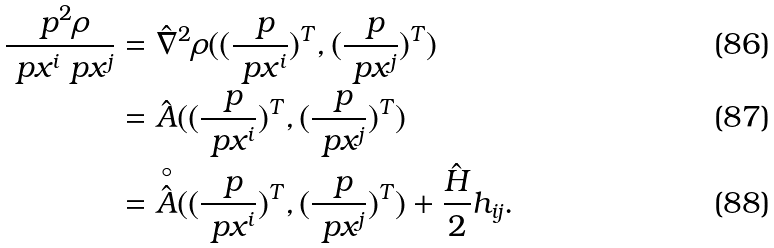<formula> <loc_0><loc_0><loc_500><loc_500>\frac { \ p ^ { 2 } \rho } { \ p x ^ { i } \ p x ^ { j } } & = \hat { \nabla } ^ { 2 } \rho ( ( \frac { \ p } { \ p x ^ { i } } ) ^ { T } , ( \frac { \ p } { \ p x ^ { j } } ) ^ { T } ) \\ & = \hat { A } ( ( \frac { \ p } { \ p x ^ { i } } ) ^ { T } , ( \frac { \ p } { \ p x ^ { j } } ) ^ { T } ) \\ & = \overset { \circ } { \hat { A } } ( ( \frac { \ p } { \ p x ^ { i } } ) ^ { T } , ( \frac { \ p } { \ p x ^ { j } } ) ^ { T } ) + \frac { \hat { H } } { 2 } h _ { i j } .</formula> 